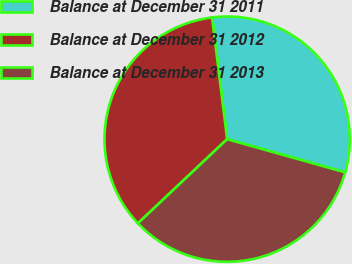<chart> <loc_0><loc_0><loc_500><loc_500><pie_chart><fcel>Balance at December 31 2011<fcel>Balance at December 31 2012<fcel>Balance at December 31 2013<nl><fcel>31.32%<fcel>35.08%<fcel>33.6%<nl></chart> 